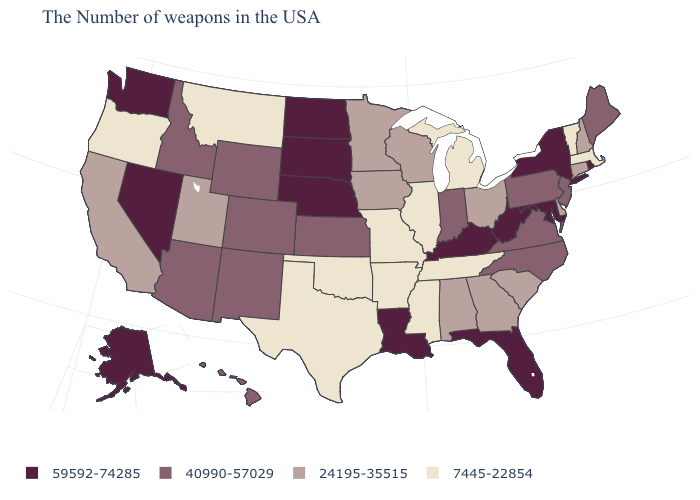What is the highest value in the MidWest ?
Concise answer only. 59592-74285. Which states hav the highest value in the MidWest?
Give a very brief answer. Nebraska, South Dakota, North Dakota. Name the states that have a value in the range 59592-74285?
Short answer required. Rhode Island, New York, Maryland, West Virginia, Florida, Kentucky, Louisiana, Nebraska, South Dakota, North Dakota, Nevada, Washington, Alaska. Among the states that border Pennsylvania , which have the highest value?
Be succinct. New York, Maryland, West Virginia. What is the value of Idaho?
Quick response, please. 40990-57029. How many symbols are there in the legend?
Short answer required. 4. Among the states that border Nebraska , does Missouri have the lowest value?
Keep it brief. Yes. Name the states that have a value in the range 40990-57029?
Write a very short answer. Maine, New Jersey, Pennsylvania, Virginia, North Carolina, Indiana, Kansas, Wyoming, Colorado, New Mexico, Arizona, Idaho, Hawaii. What is the lowest value in states that border Kentucky?
Short answer required. 7445-22854. Name the states that have a value in the range 40990-57029?
Quick response, please. Maine, New Jersey, Pennsylvania, Virginia, North Carolina, Indiana, Kansas, Wyoming, Colorado, New Mexico, Arizona, Idaho, Hawaii. What is the value of Utah?
Concise answer only. 24195-35515. Does Virginia have a higher value than Oklahoma?
Quick response, please. Yes. What is the highest value in the South ?
Write a very short answer. 59592-74285. Name the states that have a value in the range 7445-22854?
Give a very brief answer. Massachusetts, Vermont, Michigan, Tennessee, Illinois, Mississippi, Missouri, Arkansas, Oklahoma, Texas, Montana, Oregon. 